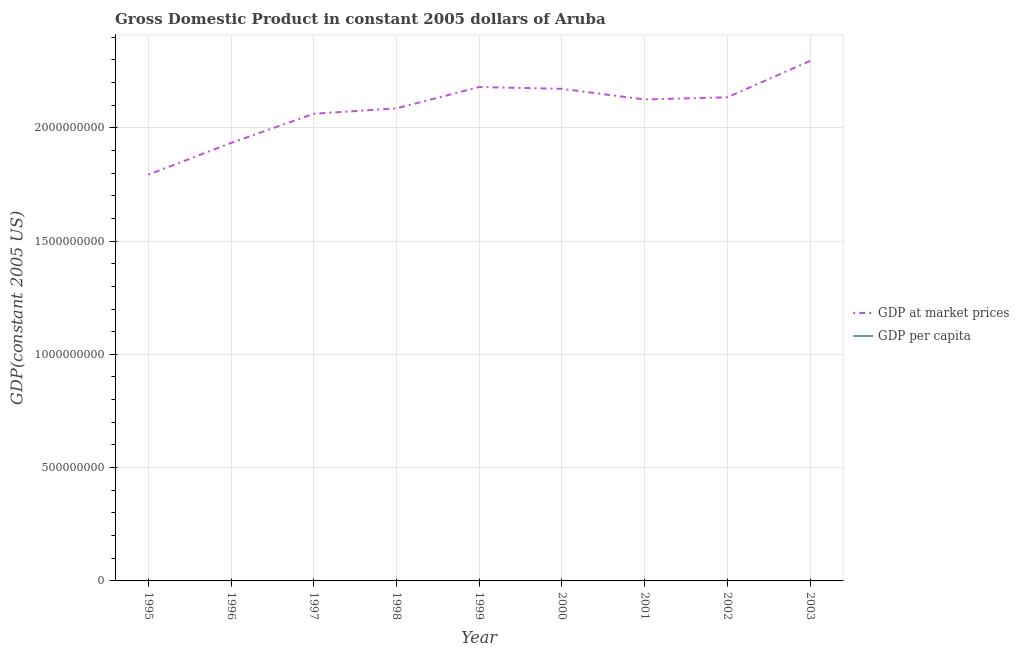Is the number of lines equal to the number of legend labels?
Offer a terse response. Yes. What is the gdp at market prices in 1995?
Your answer should be very brief. 1.79e+09. Across all years, what is the maximum gdp at market prices?
Your answer should be very brief. 2.30e+09. Across all years, what is the minimum gdp at market prices?
Your answer should be compact. 1.79e+09. In which year was the gdp per capita maximum?
Provide a succinct answer. 1999. In which year was the gdp at market prices minimum?
Offer a very short reply. 1995. What is the total gdp at market prices in the graph?
Give a very brief answer. 1.88e+1. What is the difference between the gdp per capita in 1995 and that in 2000?
Make the answer very short. -1583.68. What is the difference between the gdp at market prices in 2003 and the gdp per capita in 1995?
Make the answer very short. 2.30e+09. What is the average gdp per capita per year?
Provide a short and direct response. 2.34e+04. In the year 1996, what is the difference between the gdp at market prices and gdp per capita?
Provide a short and direct response. 1.93e+09. What is the ratio of the gdp per capita in 1998 to that in 2000?
Your response must be concise. 1. Is the gdp per capita in 1999 less than that in 2003?
Offer a terse response. No. Is the difference between the gdp at market prices in 1999 and 2000 greater than the difference between the gdp per capita in 1999 and 2000?
Keep it short and to the point. Yes. What is the difference between the highest and the second highest gdp per capita?
Your answer should be compact. 360.87. What is the difference between the highest and the lowest gdp per capita?
Make the answer very short. 2170.9. In how many years, is the gdp per capita greater than the average gdp per capita taken over all years?
Make the answer very short. 5. Where does the legend appear in the graph?
Your answer should be very brief. Center right. How many legend labels are there?
Offer a terse response. 2. How are the legend labels stacked?
Make the answer very short. Vertical. What is the title of the graph?
Make the answer very short. Gross Domestic Product in constant 2005 dollars of Aruba. What is the label or title of the X-axis?
Provide a short and direct response. Year. What is the label or title of the Y-axis?
Your answer should be compact. GDP(constant 2005 US). What is the GDP(constant 2005 US) in GDP at market prices in 1995?
Make the answer very short. 1.79e+09. What is the GDP(constant 2005 US) of GDP per capita in 1995?
Provide a succinct answer. 2.23e+04. What is the GDP(constant 2005 US) of GDP at market prices in 1996?
Provide a short and direct response. 1.93e+09. What is the GDP(constant 2005 US) in GDP per capita in 1996?
Offer a terse response. 2.32e+04. What is the GDP(constant 2005 US) of GDP at market prices in 1997?
Provide a short and direct response. 2.06e+09. What is the GDP(constant 2005 US) of GDP per capita in 1997?
Make the answer very short. 2.41e+04. What is the GDP(constant 2005 US) in GDP at market prices in 1998?
Offer a very short reply. 2.09e+09. What is the GDP(constant 2005 US) in GDP per capita in 1998?
Make the answer very short. 2.39e+04. What is the GDP(constant 2005 US) of GDP at market prices in 1999?
Your response must be concise. 2.18e+09. What is the GDP(constant 2005 US) in GDP per capita in 1999?
Your response must be concise. 2.45e+04. What is the GDP(constant 2005 US) in GDP at market prices in 2000?
Offer a terse response. 2.17e+09. What is the GDP(constant 2005 US) in GDP per capita in 2000?
Provide a short and direct response. 2.39e+04. What is the GDP(constant 2005 US) of GDP at market prices in 2001?
Provide a short and direct response. 2.12e+09. What is the GDP(constant 2005 US) of GDP per capita in 2001?
Make the answer very short. 2.29e+04. What is the GDP(constant 2005 US) of GDP at market prices in 2002?
Provide a succinct answer. 2.13e+09. What is the GDP(constant 2005 US) in GDP per capita in 2002?
Offer a very short reply. 2.25e+04. What is the GDP(constant 2005 US) of GDP at market prices in 2003?
Your answer should be very brief. 2.30e+09. What is the GDP(constant 2005 US) in GDP per capita in 2003?
Your response must be concise. 2.37e+04. Across all years, what is the maximum GDP(constant 2005 US) of GDP at market prices?
Offer a terse response. 2.30e+09. Across all years, what is the maximum GDP(constant 2005 US) of GDP per capita?
Provide a succinct answer. 2.45e+04. Across all years, what is the minimum GDP(constant 2005 US) in GDP at market prices?
Provide a short and direct response. 1.79e+09. Across all years, what is the minimum GDP(constant 2005 US) in GDP per capita?
Provide a succinct answer. 2.23e+04. What is the total GDP(constant 2005 US) in GDP at market prices in the graph?
Offer a terse response. 1.88e+1. What is the total GDP(constant 2005 US) of GDP per capita in the graph?
Your answer should be compact. 2.11e+05. What is the difference between the GDP(constant 2005 US) of GDP at market prices in 1995 and that in 1996?
Your answer should be compact. -1.40e+08. What is the difference between the GDP(constant 2005 US) in GDP per capita in 1995 and that in 1996?
Your answer should be compact. -914.29. What is the difference between the GDP(constant 2005 US) in GDP at market prices in 1995 and that in 1997?
Provide a short and direct response. -2.69e+08. What is the difference between the GDP(constant 2005 US) in GDP per capita in 1995 and that in 1997?
Offer a terse response. -1810.03. What is the difference between the GDP(constant 2005 US) of GDP at market prices in 1995 and that in 1998?
Your answer should be compact. -2.93e+08. What is the difference between the GDP(constant 2005 US) of GDP per capita in 1995 and that in 1998?
Your response must be concise. -1577.09. What is the difference between the GDP(constant 2005 US) in GDP at market prices in 1995 and that in 1999?
Your answer should be compact. -3.87e+08. What is the difference between the GDP(constant 2005 US) of GDP per capita in 1995 and that in 1999?
Your answer should be compact. -2170.9. What is the difference between the GDP(constant 2005 US) of GDP at market prices in 1995 and that in 2000?
Provide a succinct answer. -3.79e+08. What is the difference between the GDP(constant 2005 US) of GDP per capita in 1995 and that in 2000?
Give a very brief answer. -1583.68. What is the difference between the GDP(constant 2005 US) of GDP at market prices in 1995 and that in 2001?
Ensure brevity in your answer.  -3.32e+08. What is the difference between the GDP(constant 2005 US) of GDP per capita in 1995 and that in 2001?
Your answer should be very brief. -553.75. What is the difference between the GDP(constant 2005 US) of GDP at market prices in 1995 and that in 2002?
Your answer should be compact. -3.42e+08. What is the difference between the GDP(constant 2005 US) in GDP per capita in 1995 and that in 2002?
Provide a short and direct response. -151.95. What is the difference between the GDP(constant 2005 US) of GDP at market prices in 1995 and that in 2003?
Keep it short and to the point. -5.02e+08. What is the difference between the GDP(constant 2005 US) of GDP per capita in 1995 and that in 2003?
Your answer should be compact. -1338.59. What is the difference between the GDP(constant 2005 US) of GDP at market prices in 1996 and that in 1997?
Give a very brief answer. -1.29e+08. What is the difference between the GDP(constant 2005 US) of GDP per capita in 1996 and that in 1997?
Your answer should be compact. -895.74. What is the difference between the GDP(constant 2005 US) of GDP at market prices in 1996 and that in 1998?
Your response must be concise. -1.53e+08. What is the difference between the GDP(constant 2005 US) in GDP per capita in 1996 and that in 1998?
Your response must be concise. -662.8. What is the difference between the GDP(constant 2005 US) in GDP at market prices in 1996 and that in 1999?
Offer a very short reply. -2.47e+08. What is the difference between the GDP(constant 2005 US) of GDP per capita in 1996 and that in 1999?
Your answer should be very brief. -1256.61. What is the difference between the GDP(constant 2005 US) of GDP at market prices in 1996 and that in 2000?
Give a very brief answer. -2.39e+08. What is the difference between the GDP(constant 2005 US) of GDP per capita in 1996 and that in 2000?
Provide a short and direct response. -669.38. What is the difference between the GDP(constant 2005 US) in GDP at market prices in 1996 and that in 2001?
Offer a terse response. -1.92e+08. What is the difference between the GDP(constant 2005 US) of GDP per capita in 1996 and that in 2001?
Offer a terse response. 360.54. What is the difference between the GDP(constant 2005 US) in GDP at market prices in 1996 and that in 2002?
Your answer should be very brief. -2.02e+08. What is the difference between the GDP(constant 2005 US) in GDP per capita in 1996 and that in 2002?
Your response must be concise. 762.35. What is the difference between the GDP(constant 2005 US) of GDP at market prices in 1996 and that in 2003?
Offer a terse response. -3.62e+08. What is the difference between the GDP(constant 2005 US) in GDP per capita in 1996 and that in 2003?
Make the answer very short. -424.3. What is the difference between the GDP(constant 2005 US) in GDP at market prices in 1997 and that in 1998?
Offer a very short reply. -2.38e+07. What is the difference between the GDP(constant 2005 US) in GDP per capita in 1997 and that in 1998?
Make the answer very short. 232.94. What is the difference between the GDP(constant 2005 US) in GDP at market prices in 1997 and that in 1999?
Ensure brevity in your answer.  -1.18e+08. What is the difference between the GDP(constant 2005 US) in GDP per capita in 1997 and that in 1999?
Provide a short and direct response. -360.87. What is the difference between the GDP(constant 2005 US) of GDP at market prices in 1997 and that in 2000?
Offer a very short reply. -1.10e+08. What is the difference between the GDP(constant 2005 US) of GDP per capita in 1997 and that in 2000?
Make the answer very short. 226.35. What is the difference between the GDP(constant 2005 US) in GDP at market prices in 1997 and that in 2001?
Your answer should be compact. -6.30e+07. What is the difference between the GDP(constant 2005 US) of GDP per capita in 1997 and that in 2001?
Ensure brevity in your answer.  1256.27. What is the difference between the GDP(constant 2005 US) in GDP at market prices in 1997 and that in 2002?
Provide a succinct answer. -7.29e+07. What is the difference between the GDP(constant 2005 US) in GDP per capita in 1997 and that in 2002?
Make the answer very short. 1658.08. What is the difference between the GDP(constant 2005 US) in GDP at market prices in 1997 and that in 2003?
Your answer should be compact. -2.33e+08. What is the difference between the GDP(constant 2005 US) of GDP per capita in 1997 and that in 2003?
Your response must be concise. 471.44. What is the difference between the GDP(constant 2005 US) of GDP at market prices in 1998 and that in 1999?
Offer a very short reply. -9.41e+07. What is the difference between the GDP(constant 2005 US) of GDP per capita in 1998 and that in 1999?
Your response must be concise. -593.81. What is the difference between the GDP(constant 2005 US) in GDP at market prices in 1998 and that in 2000?
Your answer should be compact. -8.62e+07. What is the difference between the GDP(constant 2005 US) in GDP per capita in 1998 and that in 2000?
Give a very brief answer. -6.58. What is the difference between the GDP(constant 2005 US) in GDP at market prices in 1998 and that in 2001?
Your response must be concise. -3.92e+07. What is the difference between the GDP(constant 2005 US) of GDP per capita in 1998 and that in 2001?
Ensure brevity in your answer.  1023.34. What is the difference between the GDP(constant 2005 US) in GDP at market prices in 1998 and that in 2002?
Your answer should be very brief. -4.91e+07. What is the difference between the GDP(constant 2005 US) of GDP per capita in 1998 and that in 2002?
Offer a terse response. 1425.15. What is the difference between the GDP(constant 2005 US) in GDP at market prices in 1998 and that in 2003?
Ensure brevity in your answer.  -2.10e+08. What is the difference between the GDP(constant 2005 US) of GDP per capita in 1998 and that in 2003?
Make the answer very short. 238.5. What is the difference between the GDP(constant 2005 US) of GDP at market prices in 1999 and that in 2000?
Offer a terse response. 7.95e+06. What is the difference between the GDP(constant 2005 US) in GDP per capita in 1999 and that in 2000?
Make the answer very short. 587.22. What is the difference between the GDP(constant 2005 US) in GDP at market prices in 1999 and that in 2001?
Give a very brief answer. 5.50e+07. What is the difference between the GDP(constant 2005 US) in GDP per capita in 1999 and that in 2001?
Offer a terse response. 1617.15. What is the difference between the GDP(constant 2005 US) in GDP at market prices in 1999 and that in 2002?
Give a very brief answer. 4.51e+07. What is the difference between the GDP(constant 2005 US) of GDP per capita in 1999 and that in 2002?
Provide a succinct answer. 2018.95. What is the difference between the GDP(constant 2005 US) of GDP at market prices in 1999 and that in 2003?
Make the answer very short. -1.15e+08. What is the difference between the GDP(constant 2005 US) of GDP per capita in 1999 and that in 2003?
Offer a very short reply. 832.31. What is the difference between the GDP(constant 2005 US) of GDP at market prices in 2000 and that in 2001?
Give a very brief answer. 4.70e+07. What is the difference between the GDP(constant 2005 US) of GDP per capita in 2000 and that in 2001?
Keep it short and to the point. 1029.92. What is the difference between the GDP(constant 2005 US) of GDP at market prices in 2000 and that in 2002?
Offer a terse response. 3.71e+07. What is the difference between the GDP(constant 2005 US) in GDP per capita in 2000 and that in 2002?
Offer a terse response. 1431.73. What is the difference between the GDP(constant 2005 US) of GDP at market prices in 2000 and that in 2003?
Provide a succinct answer. -1.23e+08. What is the difference between the GDP(constant 2005 US) of GDP per capita in 2000 and that in 2003?
Provide a succinct answer. 245.08. What is the difference between the GDP(constant 2005 US) of GDP at market prices in 2001 and that in 2002?
Make the answer very short. -9.89e+06. What is the difference between the GDP(constant 2005 US) in GDP per capita in 2001 and that in 2002?
Ensure brevity in your answer.  401.81. What is the difference between the GDP(constant 2005 US) in GDP at market prices in 2001 and that in 2003?
Your answer should be compact. -1.70e+08. What is the difference between the GDP(constant 2005 US) in GDP per capita in 2001 and that in 2003?
Offer a terse response. -784.84. What is the difference between the GDP(constant 2005 US) in GDP at market prices in 2002 and that in 2003?
Provide a short and direct response. -1.61e+08. What is the difference between the GDP(constant 2005 US) of GDP per capita in 2002 and that in 2003?
Your response must be concise. -1186.65. What is the difference between the GDP(constant 2005 US) in GDP at market prices in 1995 and the GDP(constant 2005 US) in GDP per capita in 1996?
Offer a terse response. 1.79e+09. What is the difference between the GDP(constant 2005 US) in GDP at market prices in 1995 and the GDP(constant 2005 US) in GDP per capita in 1997?
Give a very brief answer. 1.79e+09. What is the difference between the GDP(constant 2005 US) in GDP at market prices in 1995 and the GDP(constant 2005 US) in GDP per capita in 1998?
Your answer should be very brief. 1.79e+09. What is the difference between the GDP(constant 2005 US) of GDP at market prices in 1995 and the GDP(constant 2005 US) of GDP per capita in 1999?
Keep it short and to the point. 1.79e+09. What is the difference between the GDP(constant 2005 US) in GDP at market prices in 1995 and the GDP(constant 2005 US) in GDP per capita in 2000?
Your answer should be compact. 1.79e+09. What is the difference between the GDP(constant 2005 US) in GDP at market prices in 1995 and the GDP(constant 2005 US) in GDP per capita in 2001?
Give a very brief answer. 1.79e+09. What is the difference between the GDP(constant 2005 US) of GDP at market prices in 1995 and the GDP(constant 2005 US) of GDP per capita in 2002?
Ensure brevity in your answer.  1.79e+09. What is the difference between the GDP(constant 2005 US) in GDP at market prices in 1995 and the GDP(constant 2005 US) in GDP per capita in 2003?
Offer a terse response. 1.79e+09. What is the difference between the GDP(constant 2005 US) of GDP at market prices in 1996 and the GDP(constant 2005 US) of GDP per capita in 1997?
Offer a terse response. 1.93e+09. What is the difference between the GDP(constant 2005 US) of GDP at market prices in 1996 and the GDP(constant 2005 US) of GDP per capita in 1998?
Keep it short and to the point. 1.93e+09. What is the difference between the GDP(constant 2005 US) of GDP at market prices in 1996 and the GDP(constant 2005 US) of GDP per capita in 1999?
Offer a very short reply. 1.93e+09. What is the difference between the GDP(constant 2005 US) in GDP at market prices in 1996 and the GDP(constant 2005 US) in GDP per capita in 2000?
Make the answer very short. 1.93e+09. What is the difference between the GDP(constant 2005 US) of GDP at market prices in 1996 and the GDP(constant 2005 US) of GDP per capita in 2001?
Provide a succinct answer. 1.93e+09. What is the difference between the GDP(constant 2005 US) in GDP at market prices in 1996 and the GDP(constant 2005 US) in GDP per capita in 2002?
Ensure brevity in your answer.  1.93e+09. What is the difference between the GDP(constant 2005 US) in GDP at market prices in 1996 and the GDP(constant 2005 US) in GDP per capita in 2003?
Provide a succinct answer. 1.93e+09. What is the difference between the GDP(constant 2005 US) in GDP at market prices in 1997 and the GDP(constant 2005 US) in GDP per capita in 1998?
Offer a terse response. 2.06e+09. What is the difference between the GDP(constant 2005 US) in GDP at market prices in 1997 and the GDP(constant 2005 US) in GDP per capita in 1999?
Offer a terse response. 2.06e+09. What is the difference between the GDP(constant 2005 US) of GDP at market prices in 1997 and the GDP(constant 2005 US) of GDP per capita in 2000?
Give a very brief answer. 2.06e+09. What is the difference between the GDP(constant 2005 US) in GDP at market prices in 1997 and the GDP(constant 2005 US) in GDP per capita in 2001?
Provide a succinct answer. 2.06e+09. What is the difference between the GDP(constant 2005 US) of GDP at market prices in 1997 and the GDP(constant 2005 US) of GDP per capita in 2002?
Keep it short and to the point. 2.06e+09. What is the difference between the GDP(constant 2005 US) of GDP at market prices in 1997 and the GDP(constant 2005 US) of GDP per capita in 2003?
Offer a terse response. 2.06e+09. What is the difference between the GDP(constant 2005 US) of GDP at market prices in 1998 and the GDP(constant 2005 US) of GDP per capita in 1999?
Give a very brief answer. 2.09e+09. What is the difference between the GDP(constant 2005 US) of GDP at market prices in 1998 and the GDP(constant 2005 US) of GDP per capita in 2000?
Keep it short and to the point. 2.09e+09. What is the difference between the GDP(constant 2005 US) in GDP at market prices in 1998 and the GDP(constant 2005 US) in GDP per capita in 2001?
Offer a very short reply. 2.09e+09. What is the difference between the GDP(constant 2005 US) in GDP at market prices in 1998 and the GDP(constant 2005 US) in GDP per capita in 2002?
Offer a terse response. 2.09e+09. What is the difference between the GDP(constant 2005 US) of GDP at market prices in 1998 and the GDP(constant 2005 US) of GDP per capita in 2003?
Your answer should be very brief. 2.09e+09. What is the difference between the GDP(constant 2005 US) of GDP at market prices in 1999 and the GDP(constant 2005 US) of GDP per capita in 2000?
Offer a very short reply. 2.18e+09. What is the difference between the GDP(constant 2005 US) of GDP at market prices in 1999 and the GDP(constant 2005 US) of GDP per capita in 2001?
Give a very brief answer. 2.18e+09. What is the difference between the GDP(constant 2005 US) of GDP at market prices in 1999 and the GDP(constant 2005 US) of GDP per capita in 2002?
Ensure brevity in your answer.  2.18e+09. What is the difference between the GDP(constant 2005 US) in GDP at market prices in 1999 and the GDP(constant 2005 US) in GDP per capita in 2003?
Offer a very short reply. 2.18e+09. What is the difference between the GDP(constant 2005 US) of GDP at market prices in 2000 and the GDP(constant 2005 US) of GDP per capita in 2001?
Provide a short and direct response. 2.17e+09. What is the difference between the GDP(constant 2005 US) of GDP at market prices in 2000 and the GDP(constant 2005 US) of GDP per capita in 2002?
Make the answer very short. 2.17e+09. What is the difference between the GDP(constant 2005 US) of GDP at market prices in 2000 and the GDP(constant 2005 US) of GDP per capita in 2003?
Give a very brief answer. 2.17e+09. What is the difference between the GDP(constant 2005 US) of GDP at market prices in 2001 and the GDP(constant 2005 US) of GDP per capita in 2002?
Provide a succinct answer. 2.12e+09. What is the difference between the GDP(constant 2005 US) of GDP at market prices in 2001 and the GDP(constant 2005 US) of GDP per capita in 2003?
Offer a very short reply. 2.12e+09. What is the difference between the GDP(constant 2005 US) of GDP at market prices in 2002 and the GDP(constant 2005 US) of GDP per capita in 2003?
Offer a terse response. 2.13e+09. What is the average GDP(constant 2005 US) in GDP at market prices per year?
Offer a very short reply. 2.09e+09. What is the average GDP(constant 2005 US) in GDP per capita per year?
Provide a succinct answer. 2.34e+04. In the year 1995, what is the difference between the GDP(constant 2005 US) in GDP at market prices and GDP(constant 2005 US) in GDP per capita?
Offer a terse response. 1.79e+09. In the year 1996, what is the difference between the GDP(constant 2005 US) in GDP at market prices and GDP(constant 2005 US) in GDP per capita?
Offer a very short reply. 1.93e+09. In the year 1997, what is the difference between the GDP(constant 2005 US) in GDP at market prices and GDP(constant 2005 US) in GDP per capita?
Give a very brief answer. 2.06e+09. In the year 1998, what is the difference between the GDP(constant 2005 US) of GDP at market prices and GDP(constant 2005 US) of GDP per capita?
Provide a succinct answer. 2.09e+09. In the year 1999, what is the difference between the GDP(constant 2005 US) of GDP at market prices and GDP(constant 2005 US) of GDP per capita?
Your answer should be compact. 2.18e+09. In the year 2000, what is the difference between the GDP(constant 2005 US) of GDP at market prices and GDP(constant 2005 US) of GDP per capita?
Offer a terse response. 2.17e+09. In the year 2001, what is the difference between the GDP(constant 2005 US) in GDP at market prices and GDP(constant 2005 US) in GDP per capita?
Ensure brevity in your answer.  2.12e+09. In the year 2002, what is the difference between the GDP(constant 2005 US) of GDP at market prices and GDP(constant 2005 US) of GDP per capita?
Your answer should be compact. 2.13e+09. In the year 2003, what is the difference between the GDP(constant 2005 US) in GDP at market prices and GDP(constant 2005 US) in GDP per capita?
Your response must be concise. 2.30e+09. What is the ratio of the GDP(constant 2005 US) of GDP at market prices in 1995 to that in 1996?
Provide a succinct answer. 0.93. What is the ratio of the GDP(constant 2005 US) of GDP per capita in 1995 to that in 1996?
Offer a very short reply. 0.96. What is the ratio of the GDP(constant 2005 US) of GDP at market prices in 1995 to that in 1997?
Make the answer very short. 0.87. What is the ratio of the GDP(constant 2005 US) of GDP per capita in 1995 to that in 1997?
Provide a succinct answer. 0.93. What is the ratio of the GDP(constant 2005 US) in GDP at market prices in 1995 to that in 1998?
Your answer should be very brief. 0.86. What is the ratio of the GDP(constant 2005 US) in GDP per capita in 1995 to that in 1998?
Offer a terse response. 0.93. What is the ratio of the GDP(constant 2005 US) of GDP at market prices in 1995 to that in 1999?
Provide a succinct answer. 0.82. What is the ratio of the GDP(constant 2005 US) in GDP per capita in 1995 to that in 1999?
Provide a succinct answer. 0.91. What is the ratio of the GDP(constant 2005 US) in GDP at market prices in 1995 to that in 2000?
Offer a terse response. 0.83. What is the ratio of the GDP(constant 2005 US) in GDP per capita in 1995 to that in 2000?
Ensure brevity in your answer.  0.93. What is the ratio of the GDP(constant 2005 US) in GDP at market prices in 1995 to that in 2001?
Give a very brief answer. 0.84. What is the ratio of the GDP(constant 2005 US) in GDP per capita in 1995 to that in 2001?
Keep it short and to the point. 0.98. What is the ratio of the GDP(constant 2005 US) of GDP at market prices in 1995 to that in 2002?
Your response must be concise. 0.84. What is the ratio of the GDP(constant 2005 US) in GDP per capita in 1995 to that in 2002?
Give a very brief answer. 0.99. What is the ratio of the GDP(constant 2005 US) of GDP at market prices in 1995 to that in 2003?
Ensure brevity in your answer.  0.78. What is the ratio of the GDP(constant 2005 US) in GDP per capita in 1995 to that in 2003?
Provide a succinct answer. 0.94. What is the ratio of the GDP(constant 2005 US) of GDP per capita in 1996 to that in 1997?
Offer a very short reply. 0.96. What is the ratio of the GDP(constant 2005 US) in GDP at market prices in 1996 to that in 1998?
Your answer should be very brief. 0.93. What is the ratio of the GDP(constant 2005 US) in GDP per capita in 1996 to that in 1998?
Make the answer very short. 0.97. What is the ratio of the GDP(constant 2005 US) in GDP at market prices in 1996 to that in 1999?
Your answer should be very brief. 0.89. What is the ratio of the GDP(constant 2005 US) in GDP per capita in 1996 to that in 1999?
Your response must be concise. 0.95. What is the ratio of the GDP(constant 2005 US) of GDP at market prices in 1996 to that in 2000?
Ensure brevity in your answer.  0.89. What is the ratio of the GDP(constant 2005 US) of GDP per capita in 1996 to that in 2000?
Provide a succinct answer. 0.97. What is the ratio of the GDP(constant 2005 US) of GDP at market prices in 1996 to that in 2001?
Provide a short and direct response. 0.91. What is the ratio of the GDP(constant 2005 US) in GDP per capita in 1996 to that in 2001?
Ensure brevity in your answer.  1.02. What is the ratio of the GDP(constant 2005 US) in GDP at market prices in 1996 to that in 2002?
Your answer should be compact. 0.91. What is the ratio of the GDP(constant 2005 US) in GDP per capita in 1996 to that in 2002?
Provide a succinct answer. 1.03. What is the ratio of the GDP(constant 2005 US) in GDP at market prices in 1996 to that in 2003?
Ensure brevity in your answer.  0.84. What is the ratio of the GDP(constant 2005 US) of GDP per capita in 1996 to that in 2003?
Ensure brevity in your answer.  0.98. What is the ratio of the GDP(constant 2005 US) in GDP at market prices in 1997 to that in 1998?
Offer a terse response. 0.99. What is the ratio of the GDP(constant 2005 US) in GDP per capita in 1997 to that in 1998?
Offer a terse response. 1.01. What is the ratio of the GDP(constant 2005 US) of GDP at market prices in 1997 to that in 1999?
Your answer should be compact. 0.95. What is the ratio of the GDP(constant 2005 US) of GDP at market prices in 1997 to that in 2000?
Give a very brief answer. 0.95. What is the ratio of the GDP(constant 2005 US) of GDP per capita in 1997 to that in 2000?
Provide a short and direct response. 1.01. What is the ratio of the GDP(constant 2005 US) of GDP at market prices in 1997 to that in 2001?
Ensure brevity in your answer.  0.97. What is the ratio of the GDP(constant 2005 US) of GDP per capita in 1997 to that in 2001?
Your answer should be compact. 1.05. What is the ratio of the GDP(constant 2005 US) in GDP at market prices in 1997 to that in 2002?
Offer a terse response. 0.97. What is the ratio of the GDP(constant 2005 US) of GDP per capita in 1997 to that in 2002?
Give a very brief answer. 1.07. What is the ratio of the GDP(constant 2005 US) of GDP at market prices in 1997 to that in 2003?
Give a very brief answer. 0.9. What is the ratio of the GDP(constant 2005 US) in GDP per capita in 1997 to that in 2003?
Offer a very short reply. 1.02. What is the ratio of the GDP(constant 2005 US) of GDP at market prices in 1998 to that in 1999?
Offer a very short reply. 0.96. What is the ratio of the GDP(constant 2005 US) in GDP per capita in 1998 to that in 1999?
Offer a terse response. 0.98. What is the ratio of the GDP(constant 2005 US) of GDP at market prices in 1998 to that in 2000?
Keep it short and to the point. 0.96. What is the ratio of the GDP(constant 2005 US) of GDP per capita in 1998 to that in 2000?
Provide a succinct answer. 1. What is the ratio of the GDP(constant 2005 US) of GDP at market prices in 1998 to that in 2001?
Your answer should be compact. 0.98. What is the ratio of the GDP(constant 2005 US) of GDP per capita in 1998 to that in 2001?
Make the answer very short. 1.04. What is the ratio of the GDP(constant 2005 US) of GDP per capita in 1998 to that in 2002?
Your answer should be compact. 1.06. What is the ratio of the GDP(constant 2005 US) of GDP at market prices in 1998 to that in 2003?
Give a very brief answer. 0.91. What is the ratio of the GDP(constant 2005 US) of GDP at market prices in 1999 to that in 2000?
Offer a terse response. 1. What is the ratio of the GDP(constant 2005 US) of GDP per capita in 1999 to that in 2000?
Make the answer very short. 1.02. What is the ratio of the GDP(constant 2005 US) in GDP at market prices in 1999 to that in 2001?
Your response must be concise. 1.03. What is the ratio of the GDP(constant 2005 US) of GDP per capita in 1999 to that in 2001?
Your answer should be very brief. 1.07. What is the ratio of the GDP(constant 2005 US) of GDP at market prices in 1999 to that in 2002?
Provide a succinct answer. 1.02. What is the ratio of the GDP(constant 2005 US) of GDP per capita in 1999 to that in 2002?
Make the answer very short. 1.09. What is the ratio of the GDP(constant 2005 US) of GDP at market prices in 1999 to that in 2003?
Make the answer very short. 0.95. What is the ratio of the GDP(constant 2005 US) of GDP per capita in 1999 to that in 2003?
Give a very brief answer. 1.04. What is the ratio of the GDP(constant 2005 US) of GDP at market prices in 2000 to that in 2001?
Offer a terse response. 1.02. What is the ratio of the GDP(constant 2005 US) in GDP per capita in 2000 to that in 2001?
Give a very brief answer. 1.04. What is the ratio of the GDP(constant 2005 US) in GDP at market prices in 2000 to that in 2002?
Your answer should be very brief. 1.02. What is the ratio of the GDP(constant 2005 US) of GDP per capita in 2000 to that in 2002?
Give a very brief answer. 1.06. What is the ratio of the GDP(constant 2005 US) in GDP at market prices in 2000 to that in 2003?
Ensure brevity in your answer.  0.95. What is the ratio of the GDP(constant 2005 US) in GDP per capita in 2000 to that in 2003?
Offer a very short reply. 1.01. What is the ratio of the GDP(constant 2005 US) in GDP per capita in 2001 to that in 2002?
Keep it short and to the point. 1.02. What is the ratio of the GDP(constant 2005 US) of GDP at market prices in 2001 to that in 2003?
Provide a succinct answer. 0.93. What is the ratio of the GDP(constant 2005 US) of GDP per capita in 2001 to that in 2003?
Your answer should be very brief. 0.97. What is the ratio of the GDP(constant 2005 US) in GDP at market prices in 2002 to that in 2003?
Ensure brevity in your answer.  0.93. What is the ratio of the GDP(constant 2005 US) of GDP per capita in 2002 to that in 2003?
Your response must be concise. 0.95. What is the difference between the highest and the second highest GDP(constant 2005 US) in GDP at market prices?
Your answer should be very brief. 1.15e+08. What is the difference between the highest and the second highest GDP(constant 2005 US) of GDP per capita?
Provide a succinct answer. 360.87. What is the difference between the highest and the lowest GDP(constant 2005 US) of GDP at market prices?
Make the answer very short. 5.02e+08. What is the difference between the highest and the lowest GDP(constant 2005 US) in GDP per capita?
Ensure brevity in your answer.  2170.9. 